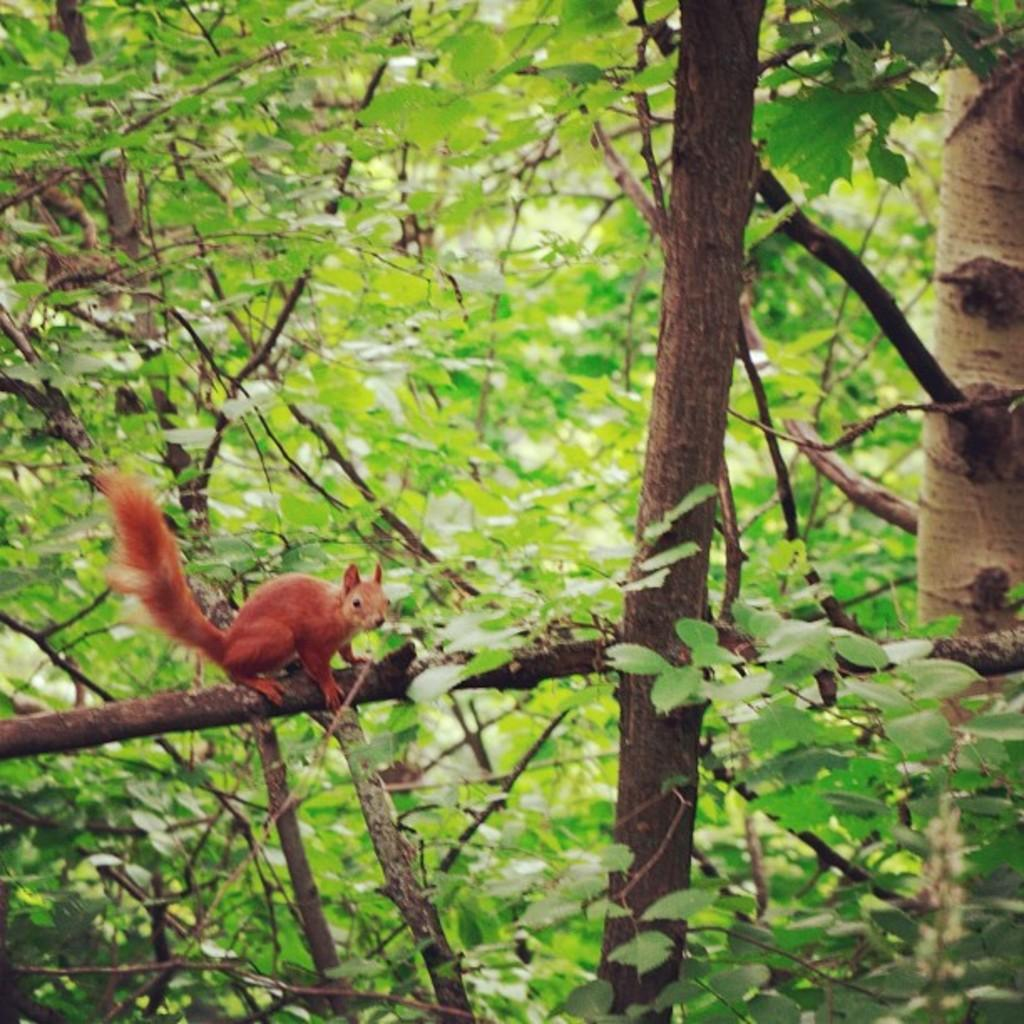What type of environment is shown in the image? The image appears to depict a forest. What is a prominent feature of the forest? There are many trees in the image. Can you describe any animals present in the image? Yes, there is a squirrel on a stem on the left side of the image. How does the sheep contribute to the image? There is no sheep present in the image. 